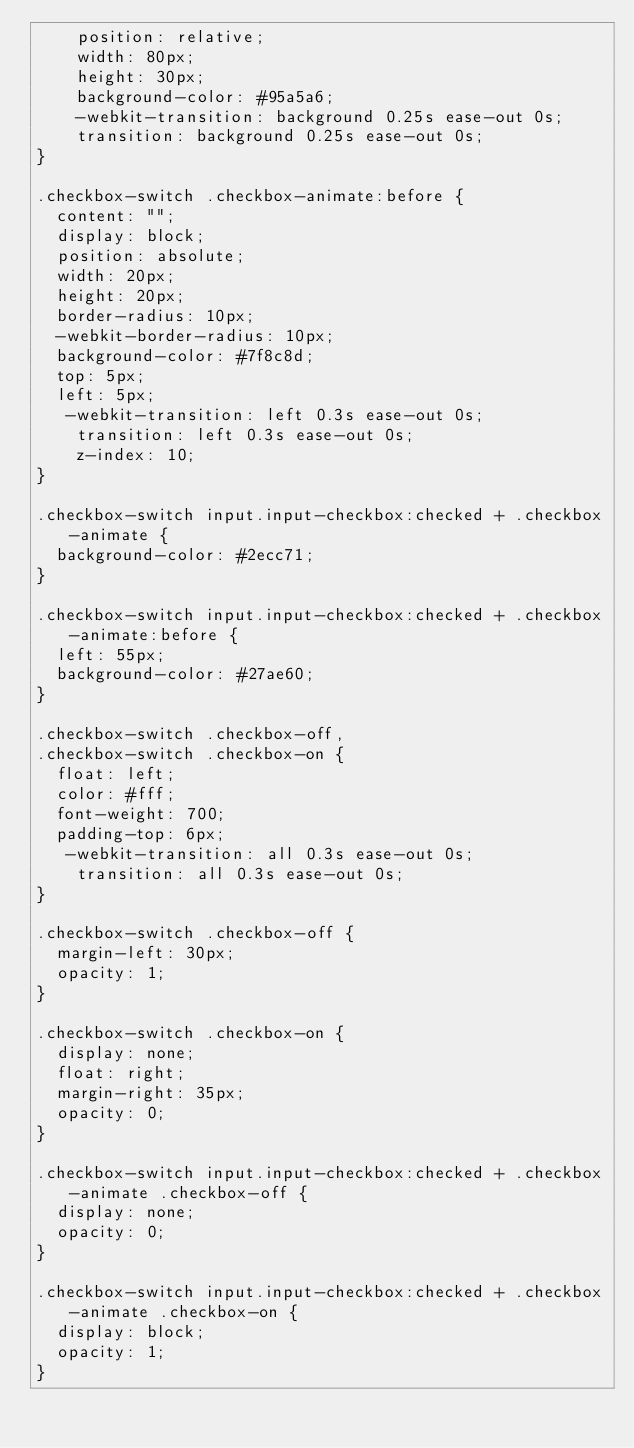<code> <loc_0><loc_0><loc_500><loc_500><_CSS_>    position: relative;
    width: 80px;
    height: 30px;
    background-color: #95a5a6;
    -webkit-transition: background 0.25s ease-out 0s;
    transition: background 0.25s ease-out 0s;
}

.checkbox-switch .checkbox-animate:before {
  content: "";
  display: block;
  position: absolute;
  width: 20px;
  height: 20px;
  border-radius: 10px;
  -webkit-border-radius: 10px;
  background-color: #7f8c8d;
  top: 5px;
  left: 5px;
   -webkit-transition: left 0.3s ease-out 0s;
    transition: left 0.3s ease-out 0s;
    z-index: 10;
}

.checkbox-switch input.input-checkbox:checked + .checkbox-animate {
  background-color: #2ecc71;
}

.checkbox-switch input.input-checkbox:checked + .checkbox-animate:before {
  left: 55px;
  background-color: #27ae60;
}

.checkbox-switch .checkbox-off,
.checkbox-switch .checkbox-on {
  float: left;
  color: #fff;
  font-weight: 700;
  padding-top: 6px;
   -webkit-transition: all 0.3s ease-out 0s;
    transition: all 0.3s ease-out 0s;
}

.checkbox-switch .checkbox-off {
  margin-left: 30px;
  opacity: 1;
}

.checkbox-switch .checkbox-on {
  display: none;
  float: right;
  margin-right: 35px;
  opacity: 0;
}

.checkbox-switch input.input-checkbox:checked + .checkbox-animate .checkbox-off {
  display: none;
  opacity: 0;
}

.checkbox-switch input.input-checkbox:checked + .checkbox-animate .checkbox-on {
  display: block;
  opacity: 1;
}
</code> 